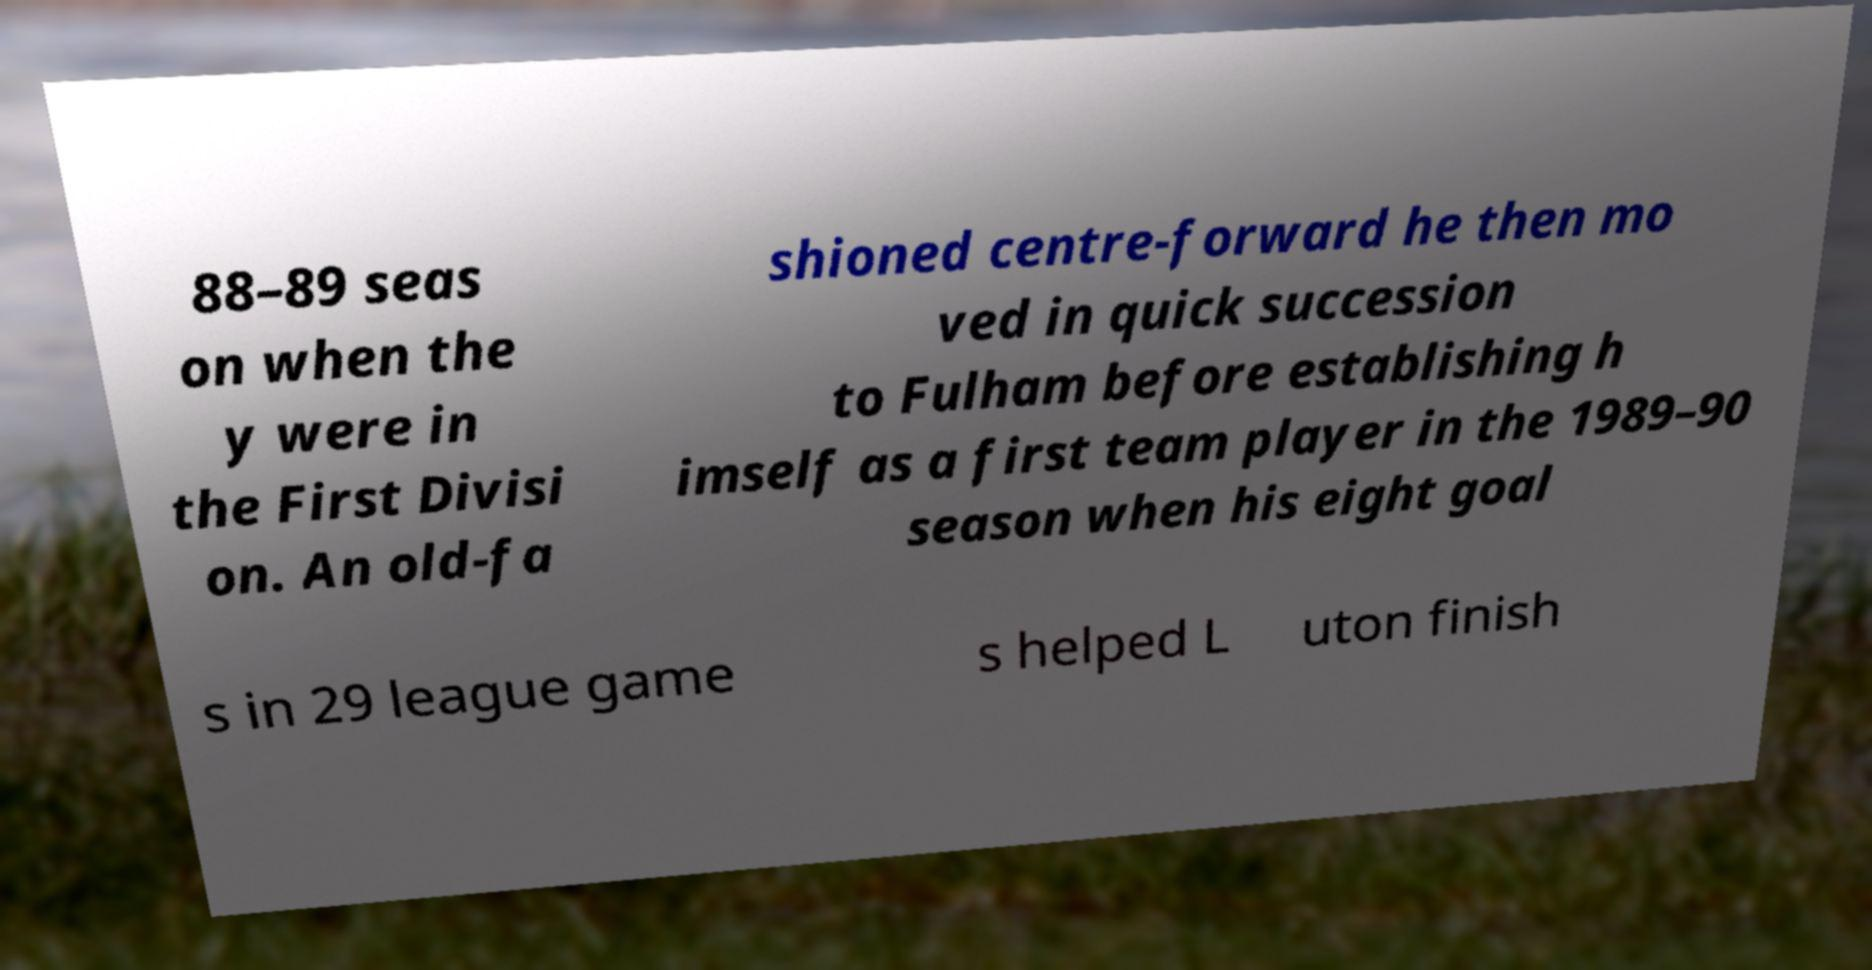Could you extract and type out the text from this image? 88–89 seas on when the y were in the First Divisi on. An old-fa shioned centre-forward he then mo ved in quick succession to Fulham before establishing h imself as a first team player in the 1989–90 season when his eight goal s in 29 league game s helped L uton finish 